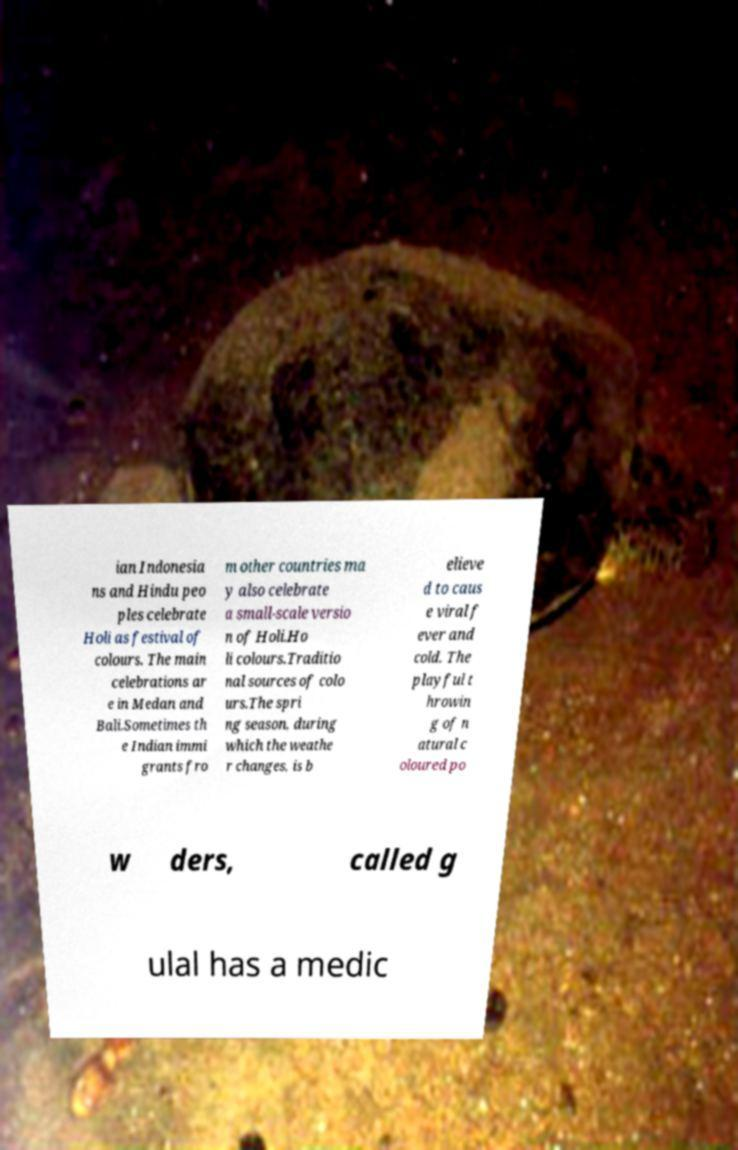Please identify and transcribe the text found in this image. ian Indonesia ns and Hindu peo ples celebrate Holi as festival of colours. The main celebrations ar e in Medan and Bali.Sometimes th e Indian immi grants fro m other countries ma y also celebrate a small-scale versio n of Holi.Ho li colours.Traditio nal sources of colo urs.The spri ng season, during which the weathe r changes, is b elieve d to caus e viral f ever and cold. The playful t hrowin g of n atural c oloured po w ders, called g ulal has a medic 